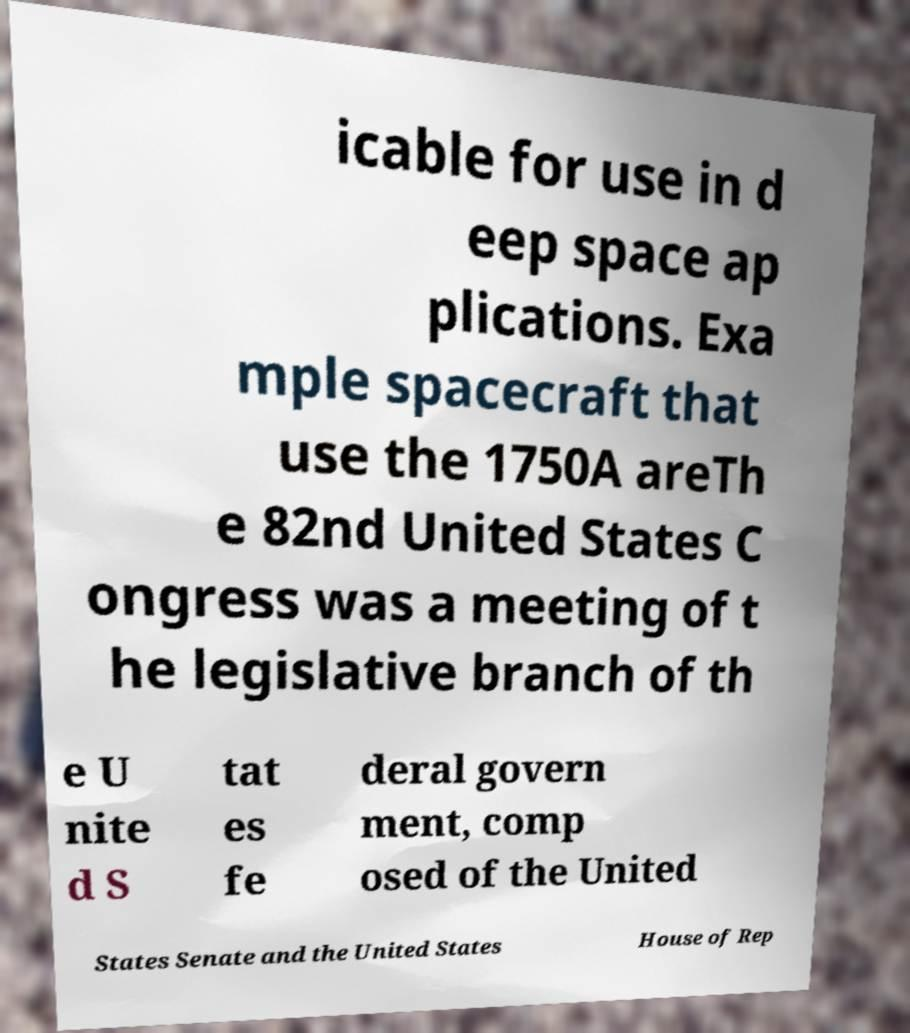Can you accurately transcribe the text from the provided image for me? icable for use in d eep space ap plications. Exa mple spacecraft that use the 1750A areTh e 82nd United States C ongress was a meeting of t he legislative branch of th e U nite d S tat es fe deral govern ment, comp osed of the United States Senate and the United States House of Rep 